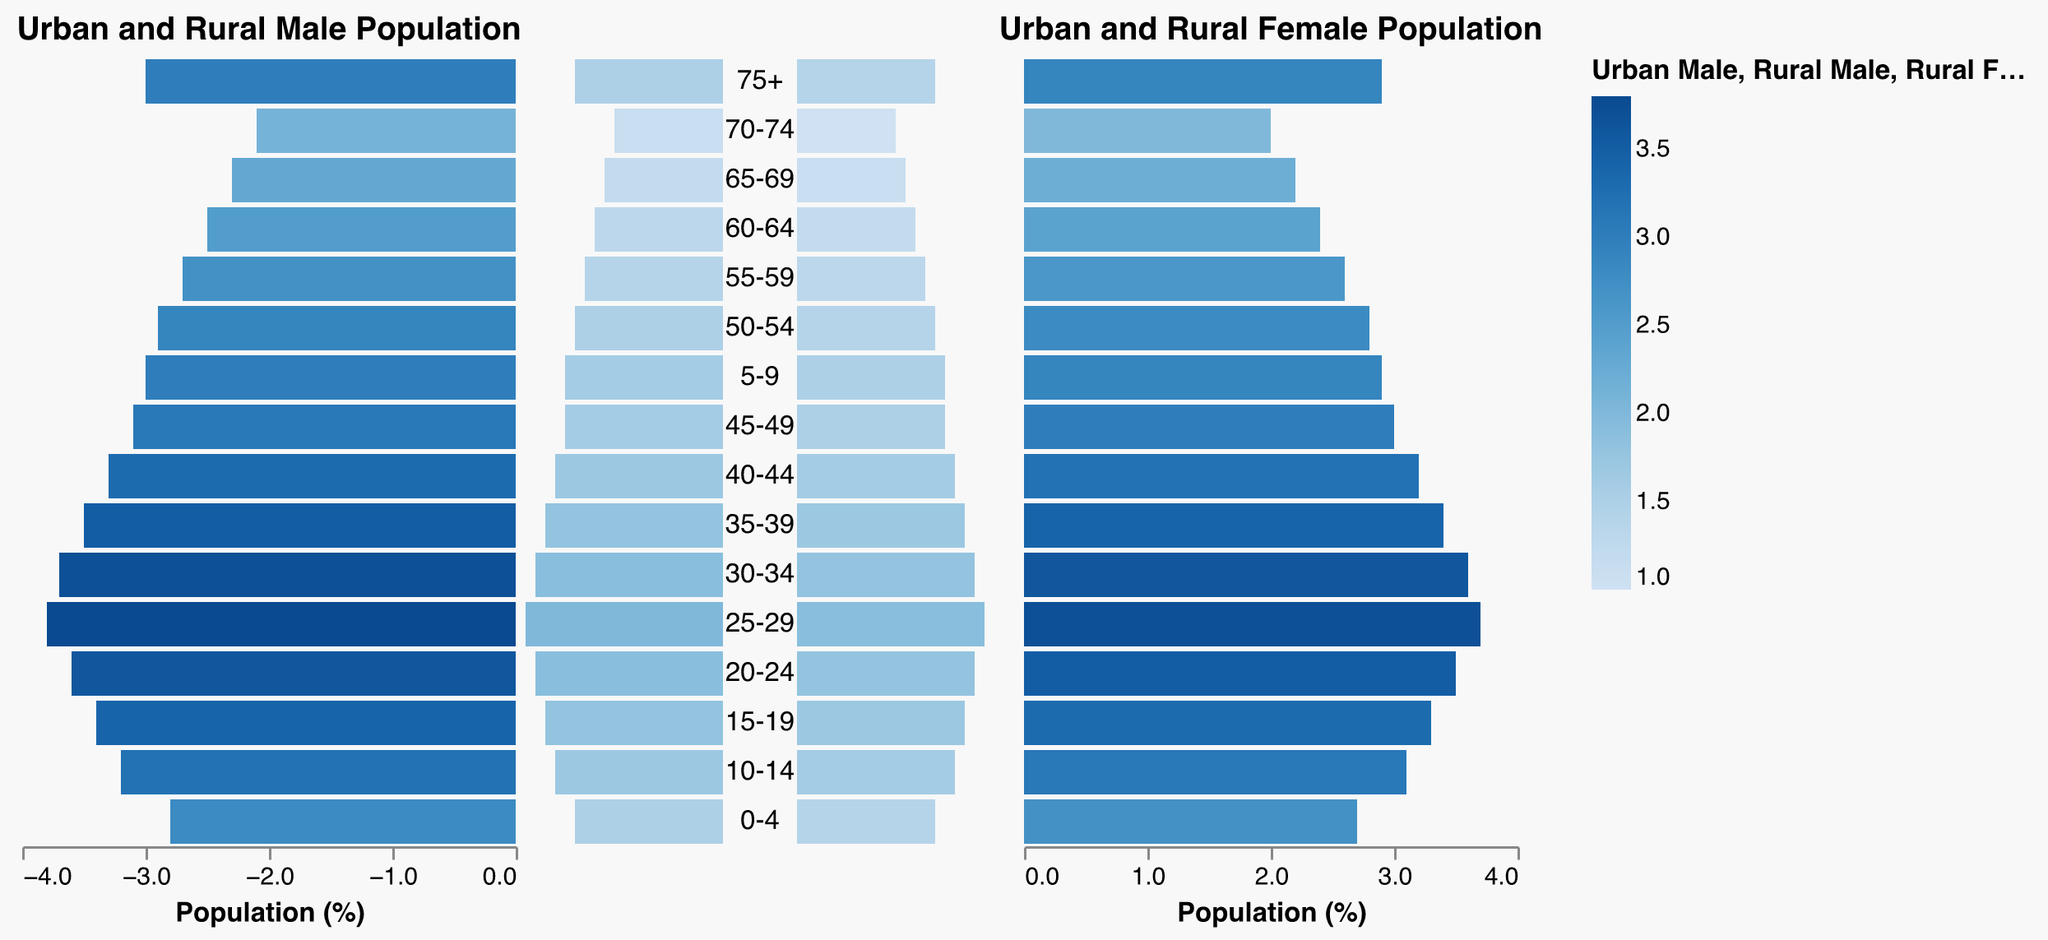What does the title of the first bar graph indicate? The title of the first bar graph is "Urban and Rural Male Population," which indicates that this section of the pyramid depicts the distribution of the male population in urban and rural areas.
Answer: Urban and Rural Male Population What is the percentage of urban males in the age group 0-4? By looking at the left-most bar for the age group 0-4, the value for urban males is -2.8%, meaning 2.8% of the total urban population are males in this age group.
Answer: 2.8% How does the access to education compare between urban and rural areas for the age group 10-14? For the age group 10-14, urban education access is at 100% while rural education access is at 92%. This indicates a disparity where urban areas have full access but rural areas have slightly lower access.
Answer: Urban: 100%, Rural: 92% In which age group is the difference in healthcare access between urban and rural areas the largest? Looking at each age group's healthcare access percentages for urban and rural areas, the largest difference is found in the age group 0-4, where urban healthcare access is 98% and rural is 75%, making the difference 23%.
Answer: 0-4 What trend can you observe in education access across different age groups in rural areas? Observing the values for rural education access from 0-4 to 75+, there is a noticeable decreasing trend. Education access starts at 85% for 0-4 and drops gradually to 40% for the 75+ age group.
Answer: Decreasing trend Compare the percentage of the urban female population to the rural female population for the 75+ age group. For the 75+ age group, the urban female population is 2.9%, while the rural female population is 1.4%. Urban areas have roughly twice the percentage of females compared to rural areas.
Answer: Urban: 2.9%, Rural: 1.4% What is the average healthcare access for urban areas across all age groups? Summing urban healthcare access percentages across all age groups and dividing by the number of age groups (17), we get: (98 + 98 + 98 + 97 + 96 + 95 + 94 + 93 + 92 + 91 + 90 + 88 + 86 + 84 + 82 + 80) / 17 = 92.24%.
Answer: 92.24% How much higher is the percentage of the urban male population in the age group 25-29 compared to the rural male population in the same age group? The urban male population percentage for the age group 25-29 is 3.8%, whereas the rural male population is 2.0%. The difference is calculated to be 3.8% - 2.0% = 1.8%.
Answer: 1.8% Which age group has the highest rural female population percentage, and what is the value? By inspecting the rural female population percentages for each age group, the age group 25-29 has the highest value, which is 1.9%.
Answer: 25-29, 1.9% How does the urban female population percentage change as age increases, particularly from 20-24 to 25-29? The percentage of the urban female population increases slightly from 3.5% in the 20-24 age group to 3.7% in the 25-29 age group.
Answer: Increases from 3.5% to 3.7% 